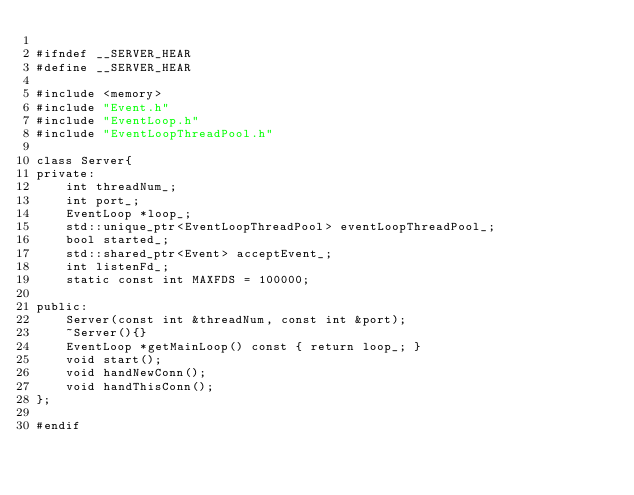Convert code to text. <code><loc_0><loc_0><loc_500><loc_500><_C_>
#ifndef __SERVER_HEAR
#define __SERVER_HEAR

#include <memory>
#include "Event.h"
#include "EventLoop.h"
#include "EventLoopThreadPool.h"

class Server{
private:
	int threadNum_;
	int port_;
	EventLoop *loop_;
	std::unique_ptr<EventLoopThreadPool> eventLoopThreadPool_;
	bool started_;
	std::shared_ptr<Event> acceptEvent_;
	int listenFd_;
	static const int MAXFDS = 100000;

public:
	Server(const int &threadNum, const int &port);
	~Server(){}
	EventLoop *getMainLoop() const { return loop_; }
	void start();
	void handNewConn();
	void handThisConn();
};

#endif
</code> 